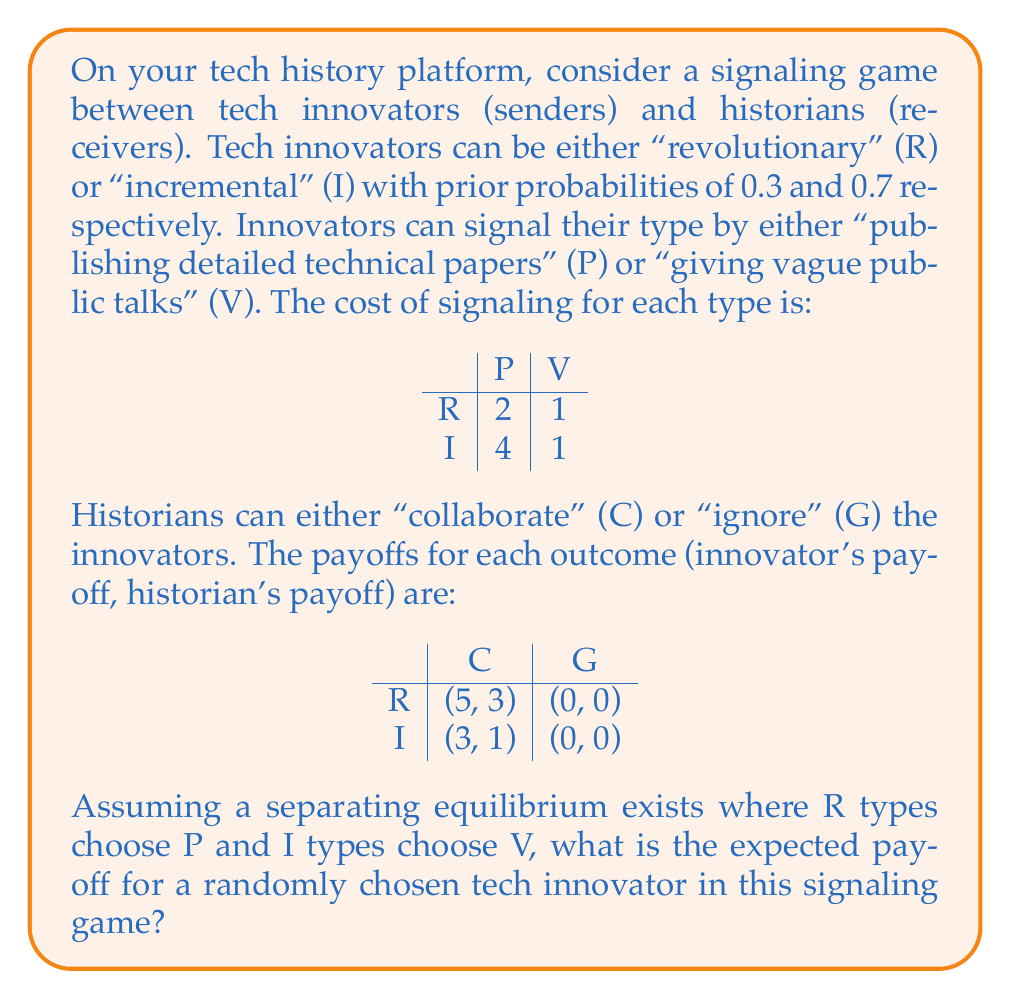Show me your answer to this math problem. To solve this problem, we need to follow these steps:

1) First, let's confirm that the separating equilibrium (R chooses P, I chooses V) is indeed possible:

   For R: $5 - 2 > 0$ (Payoff from P > Payoff from V)
   For I: $0 > 3 - 4$ (Payoff from V > Payoff from P)

   So this equilibrium can exist.

2) Now, let's calculate the expected payoff for each type:

   R type (probability 0.3):
   - Chooses P, costs 2
   - Historian will collaborate (C)
   - Payoff: $5 - 2 = 3$

   I type (probability 0.7):
   - Chooses V, costs 1
   - Historian will ignore (G)
   - Payoff: $0 - 1 = -1$

3) The expected payoff for a randomly chosen innovator is the weighted average of these payoffs:

   $$E[\text{Payoff}] = 0.3 \cdot 3 + 0.7 \cdot (-1)$$

4) Let's calculate this:

   $$E[\text{Payoff}] = 0.9 - 0.7 = 0.2$$

Therefore, the expected payoff for a randomly chosen tech innovator in this signaling game is 0.2.
Answer: The expected payoff for a randomly chosen tech innovator is $0.2$. 